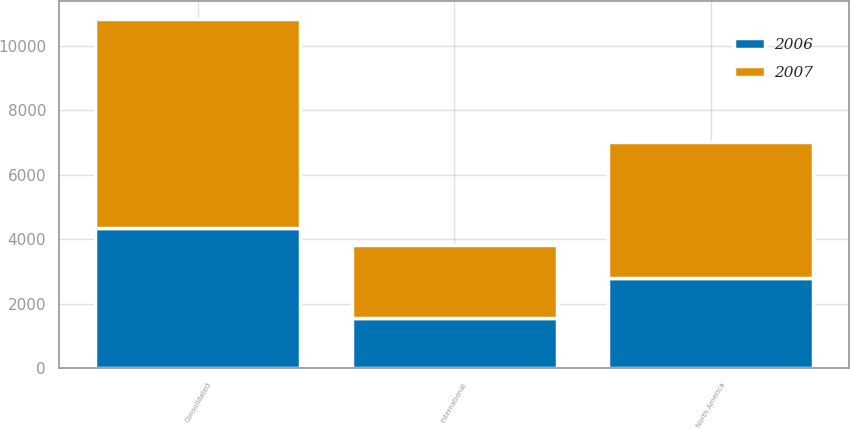Convert chart to OTSL. <chart><loc_0><loc_0><loc_500><loc_500><stacked_bar_chart><ecel><fcel>North America<fcel>International<fcel>Consolidated<nl><fcel>2007<fcel>4227<fcel>2258<fcel>6485<nl><fcel>2006<fcel>2801<fcel>1562<fcel>4363<nl></chart> 